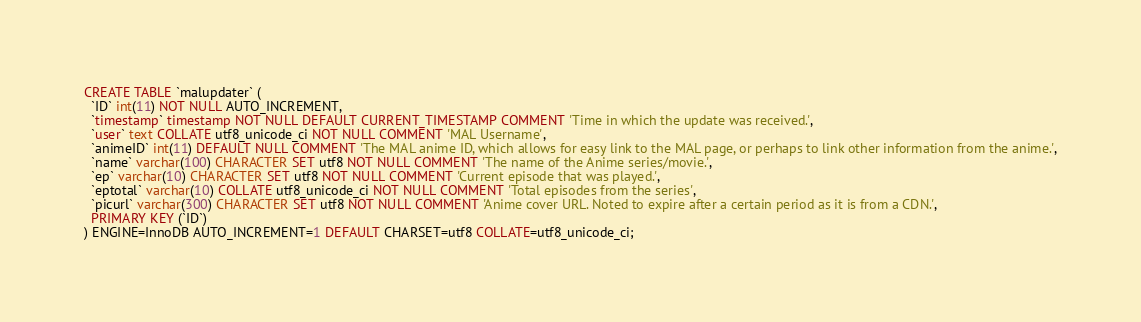Convert code to text. <code><loc_0><loc_0><loc_500><loc_500><_SQL_>CREATE TABLE `malupdater` (
  `ID` int(11) NOT NULL AUTO_INCREMENT,
  `timestamp` timestamp NOT NULL DEFAULT CURRENT_TIMESTAMP COMMENT 'Time in which the update was received.',
  `user` text COLLATE utf8_unicode_ci NOT NULL COMMENT 'MAL Username',
  `animeID` int(11) DEFAULT NULL COMMENT 'The MAL anime ID, which allows for easy link to the MAL page, or perhaps to link other information from the anime.',
  `name` varchar(100) CHARACTER SET utf8 NOT NULL COMMENT 'The name of the Anime series/movie.',
  `ep` varchar(10) CHARACTER SET utf8 NOT NULL COMMENT 'Current episode that was played.',
  `eptotal` varchar(10) COLLATE utf8_unicode_ci NOT NULL COMMENT 'Total episodes from the series',
  `picurl` varchar(300) CHARACTER SET utf8 NOT NULL COMMENT 'Anime cover URL. Noted to expire after a certain period as it is from a CDN.',
  PRIMARY KEY (`ID`)
) ENGINE=InnoDB AUTO_INCREMENT=1 DEFAULT CHARSET=utf8 COLLATE=utf8_unicode_ci;
</code> 